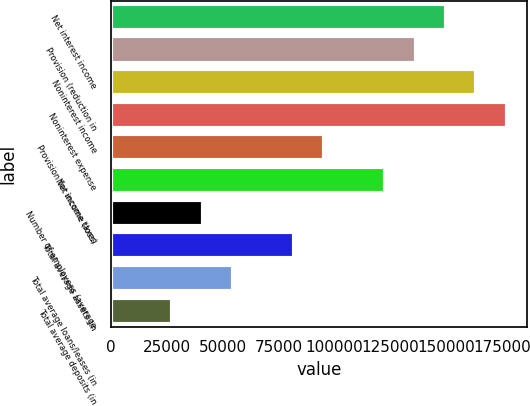Convert chart. <chart><loc_0><loc_0><loc_500><loc_500><bar_chart><fcel>Net interest income<fcel>Provision (reduction in<fcel>Noninterest income<fcel>Noninterest expense<fcel>Provision for income taxes<fcel>Net income (loss)<fcel>Number of employees (average<fcel>Total average assets (in<fcel>Total average loans/leases (in<fcel>Total average deposits (in<nl><fcel>150011<fcel>136374<fcel>163649<fcel>177286<fcel>95461.9<fcel>122737<fcel>40912.5<fcel>81824.6<fcel>54549.9<fcel>27275.2<nl></chart> 